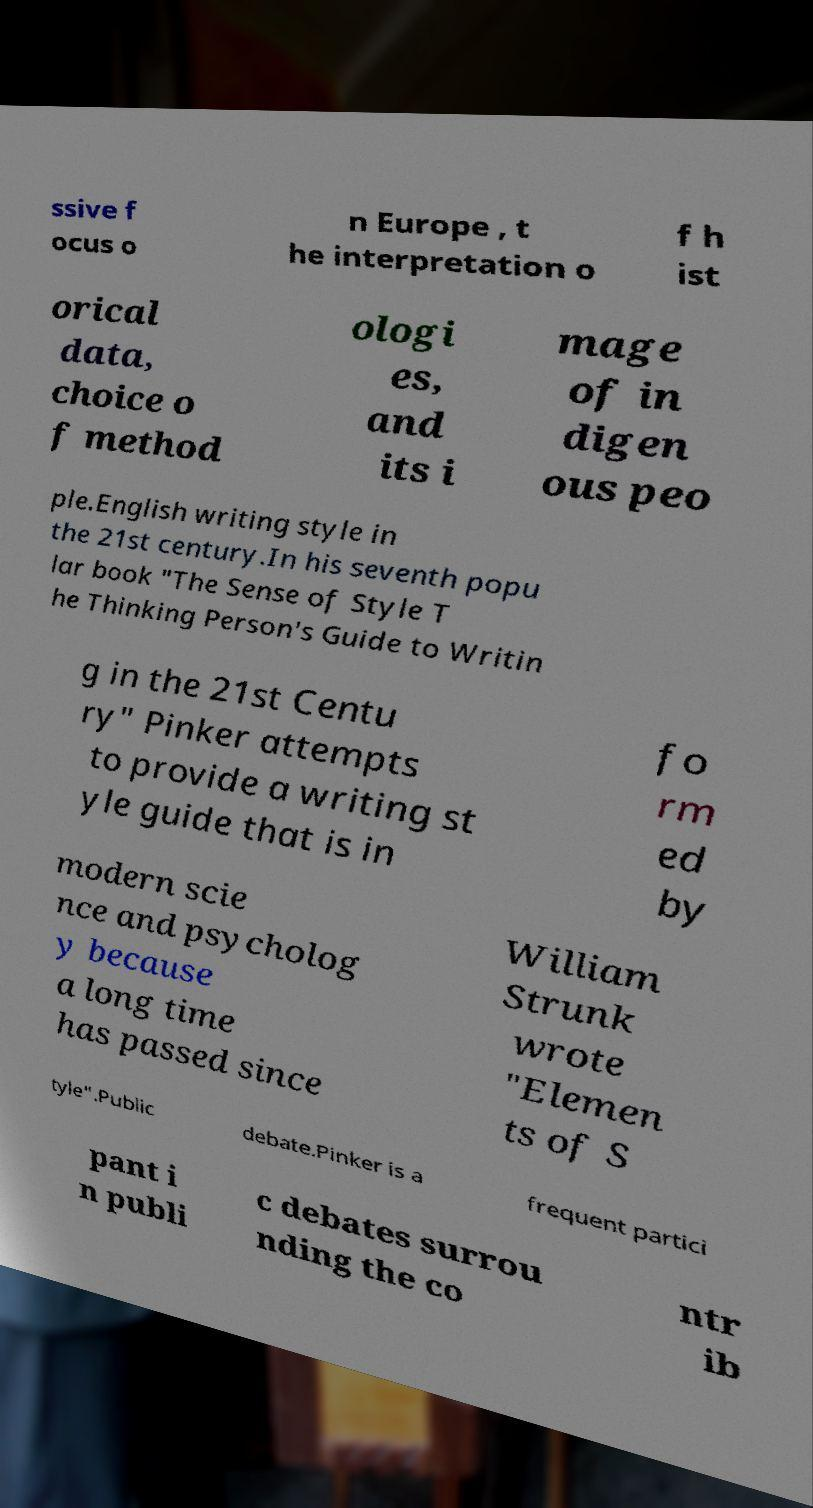Could you assist in decoding the text presented in this image and type it out clearly? ssive f ocus o n Europe , t he interpretation o f h ist orical data, choice o f method ologi es, and its i mage of in digen ous peo ple.English writing style in the 21st century.In his seventh popu lar book "The Sense of Style T he Thinking Person's Guide to Writin g in the 21st Centu ry" Pinker attempts to provide a writing st yle guide that is in fo rm ed by modern scie nce and psycholog y because a long time has passed since William Strunk wrote "Elemen ts of S tyle".Public debate.Pinker is a frequent partici pant i n publi c debates surrou nding the co ntr ib 